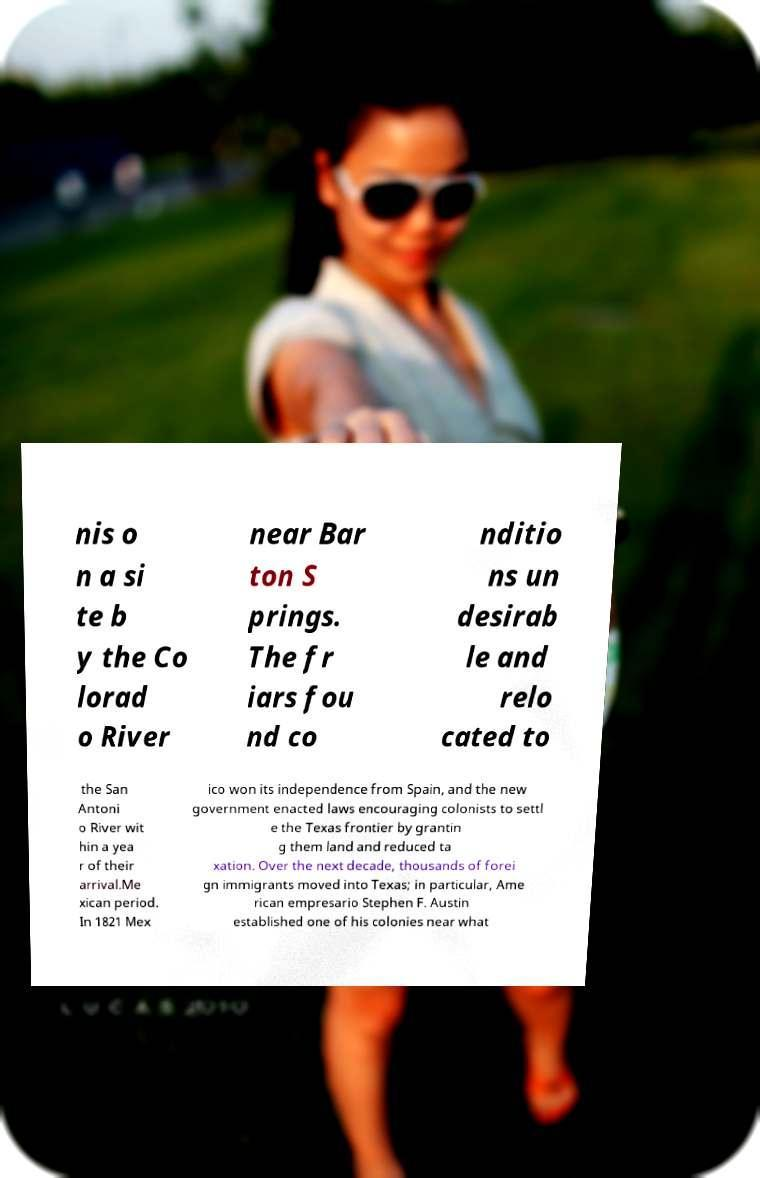Can you accurately transcribe the text from the provided image for me? nis o n a si te b y the Co lorad o River near Bar ton S prings. The fr iars fou nd co nditio ns un desirab le and relo cated to the San Antoni o River wit hin a yea r of their arrival.Me xican period. In 1821 Mex ico won its independence from Spain, and the new government enacted laws encouraging colonists to settl e the Texas frontier by grantin g them land and reduced ta xation. Over the next decade, thousands of forei gn immigrants moved into Texas; in particular, Ame rican empresario Stephen F. Austin established one of his colonies near what 